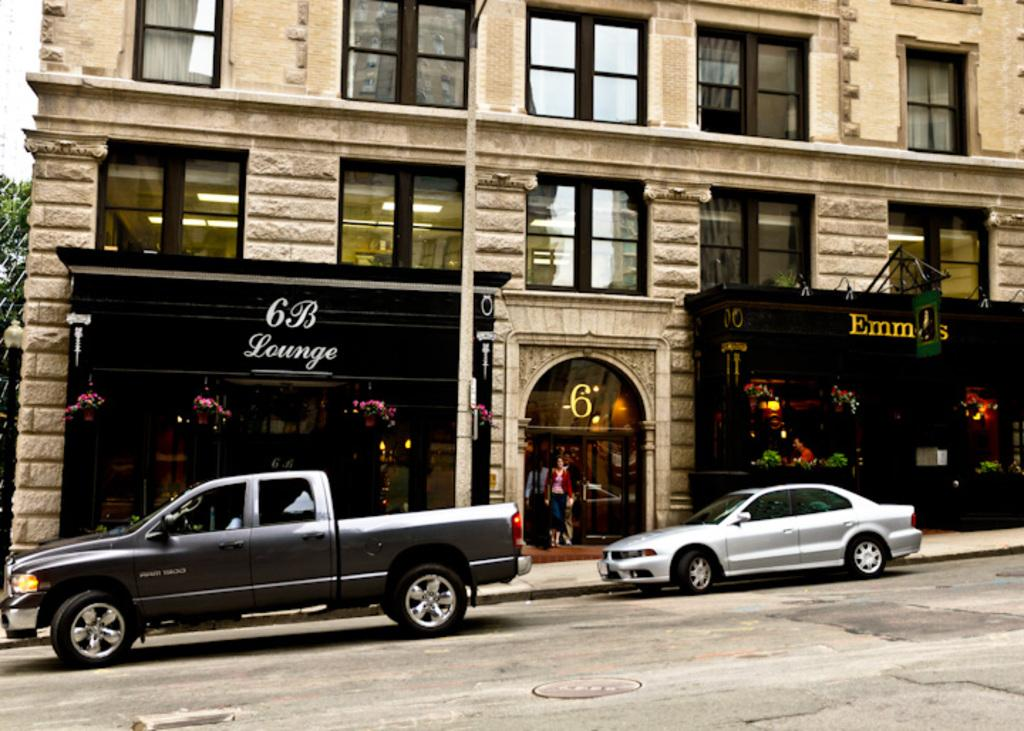What can be seen on the road in the image? There are vehicles on the road in the image. What is located in the background of the image? There is a building and a tree visible in the background of the image. What objects are present in the image that might be used for displaying information? There are boards in the image. What can be seen that might provide illumination in the image? There are lights visible in the image. What type of education can be seen in the image? There is no reference to education in the image; it features vehicles on the road, a building and a tree in the background, boards, and lights. What experience can be gained from observing the image? The image itself does not provide an experience, but observing it might lead to understanding the scene or context. 